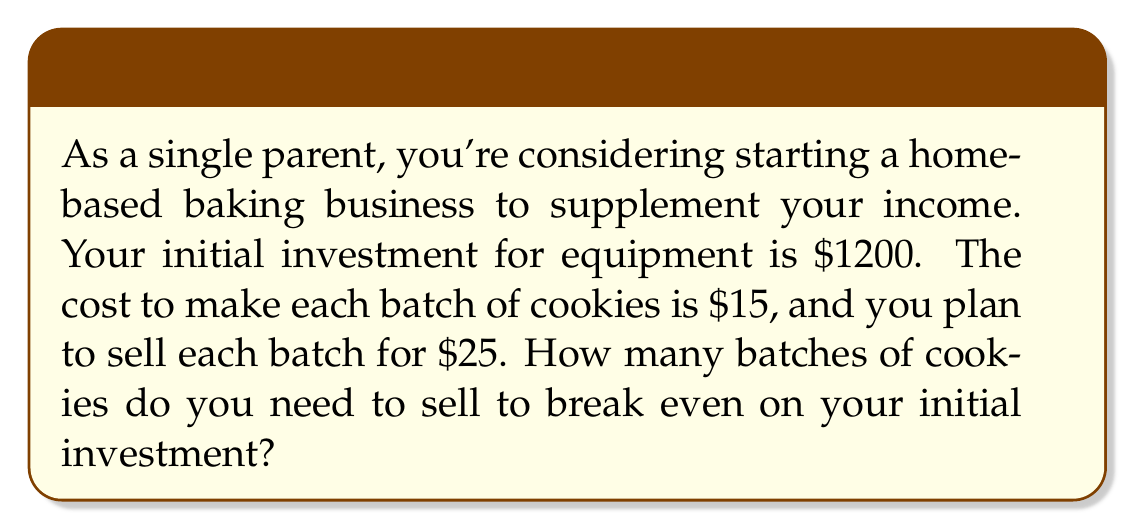Can you answer this question? To solve this problem, we need to use the break-even formula:

$$ \text{Break-even point} = \frac{\text{Fixed Costs}}{\text{Price per unit - Variable Cost per unit}} $$

Let's identify the components:

1. Fixed Costs (FC): This is your initial investment of $1200
2. Price per unit (P): $25 per batch
3. Variable Cost per unit (VC): $15 per batch

Now, let's plug these values into the formula:

$$ \text{Break-even point} = \frac{1200}{25 - 15} = \frac{1200}{10} $$

Simplifying:

$$ \text{Break-even point} = 120 $$

To verify, let's calculate the total revenue and total costs at 120 batches:

Total Revenue: $120 \times $25 = $3000
Total Costs: $1200 + (120 \times $15) = $3000

Since Total Revenue equals Total Costs at 120 batches, this confirms our break-even point.
Answer: You need to sell 120 batches of cookies to break even on your initial investment. 